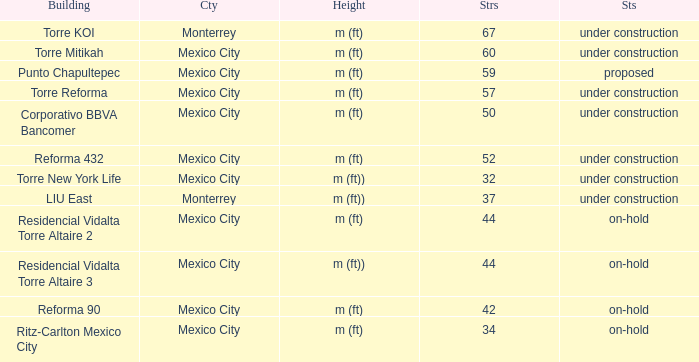How tall is the 52 story building? M (ft). 